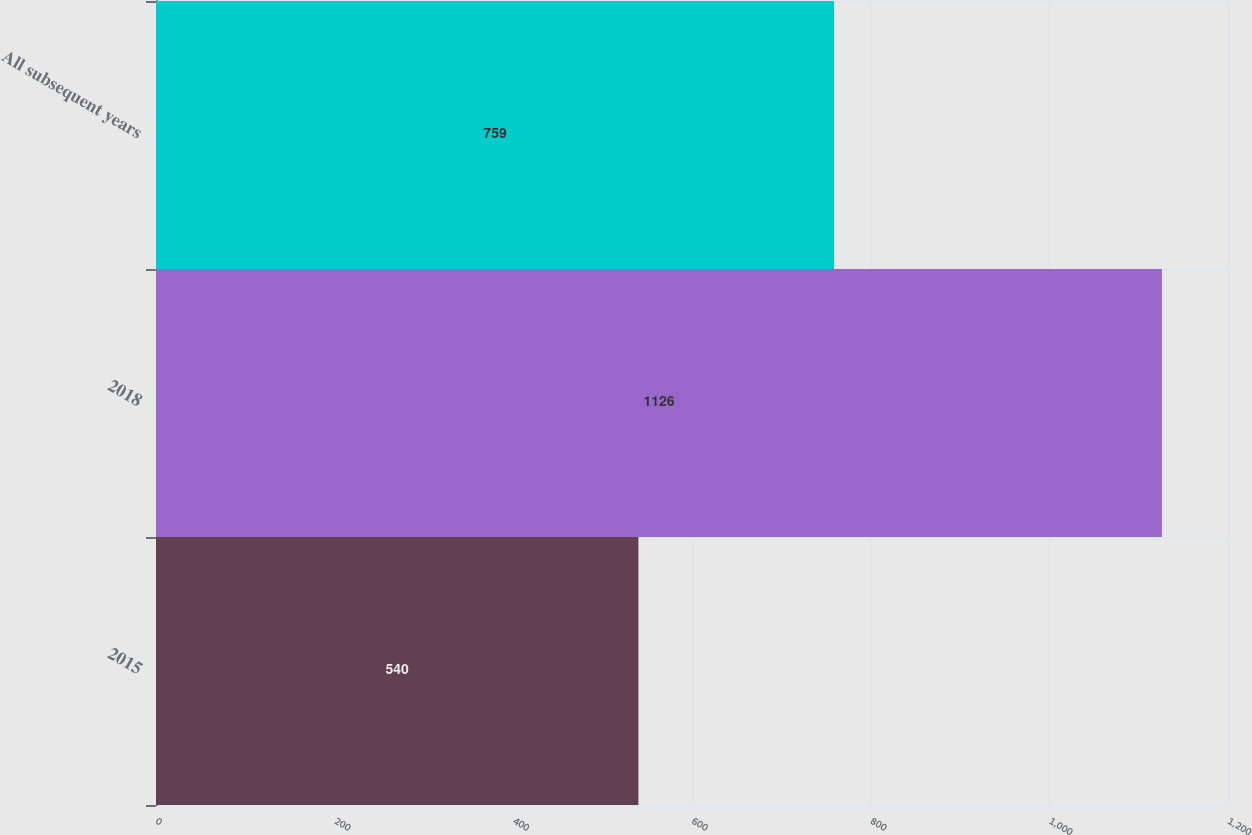Convert chart. <chart><loc_0><loc_0><loc_500><loc_500><bar_chart><fcel>2015<fcel>2018<fcel>All subsequent years<nl><fcel>540<fcel>1126<fcel>759<nl></chart> 